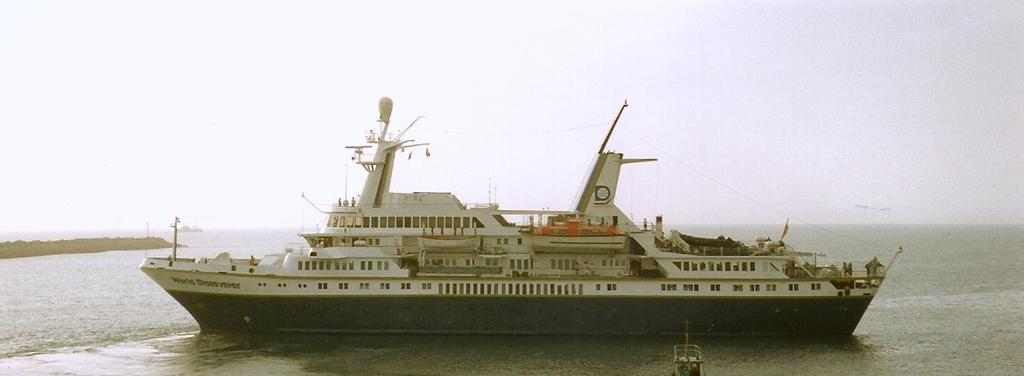What is the main subject of the image? The main subject of the image is a ship. Where is the ship located? The ship is on the water. What can be seen in the background of the image? The sky is visible in the background of the image. What type of bike does the sister ride in the image? There is no sister or bike present in the image; it features a ship on the water with the sky visible in the background. 